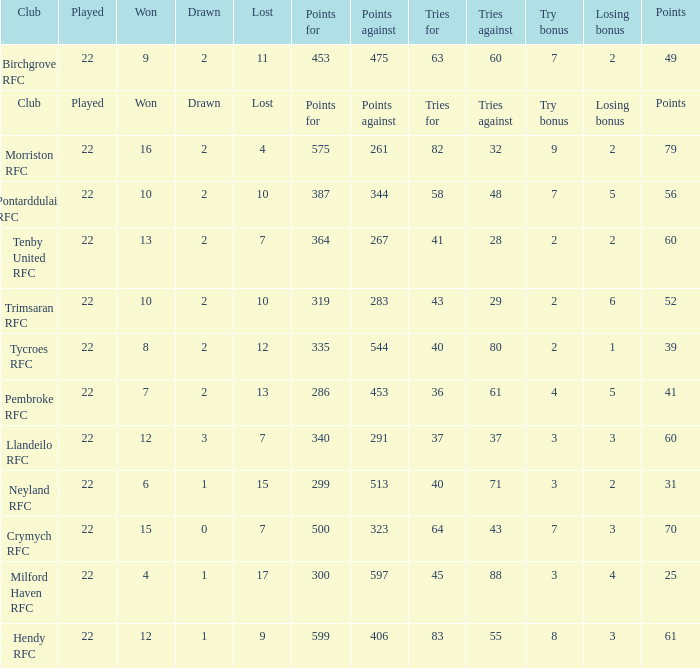What's the points with tries for being 64 70.0. 